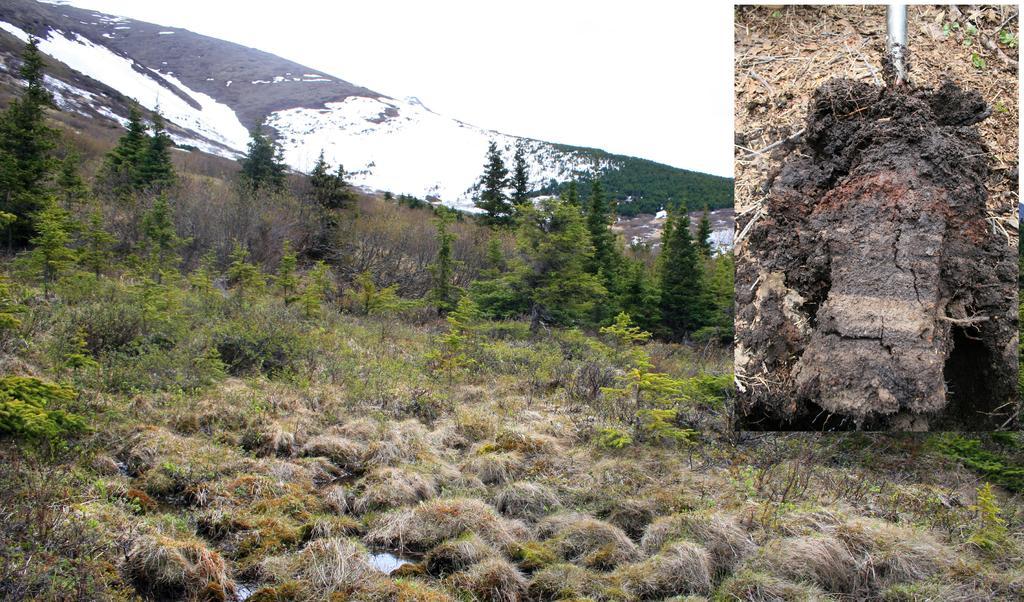Could you give a brief overview of what you see in this image? This looks like a collage picture. This is the dried grass. These are the trees and plants. I think this is a snowy mountain. This looks like a mud. 